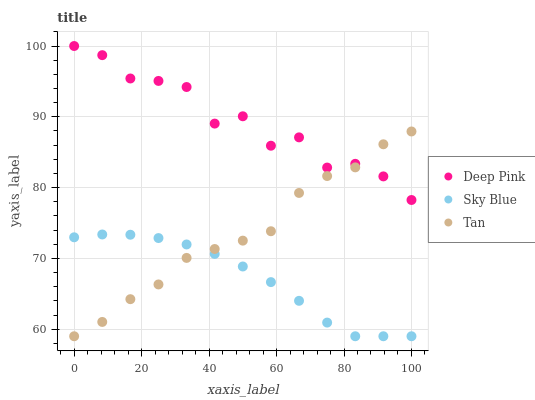Does Sky Blue have the minimum area under the curve?
Answer yes or no. Yes. Does Deep Pink have the maximum area under the curve?
Answer yes or no. Yes. Does Tan have the minimum area under the curve?
Answer yes or no. No. Does Tan have the maximum area under the curve?
Answer yes or no. No. Is Sky Blue the smoothest?
Answer yes or no. Yes. Is Deep Pink the roughest?
Answer yes or no. Yes. Is Tan the smoothest?
Answer yes or no. No. Is Tan the roughest?
Answer yes or no. No. Does Sky Blue have the lowest value?
Answer yes or no. Yes. Does Deep Pink have the lowest value?
Answer yes or no. No. Does Deep Pink have the highest value?
Answer yes or no. Yes. Does Tan have the highest value?
Answer yes or no. No. Is Sky Blue less than Deep Pink?
Answer yes or no. Yes. Is Deep Pink greater than Sky Blue?
Answer yes or no. Yes. Does Deep Pink intersect Tan?
Answer yes or no. Yes. Is Deep Pink less than Tan?
Answer yes or no. No. Is Deep Pink greater than Tan?
Answer yes or no. No. Does Sky Blue intersect Deep Pink?
Answer yes or no. No. 